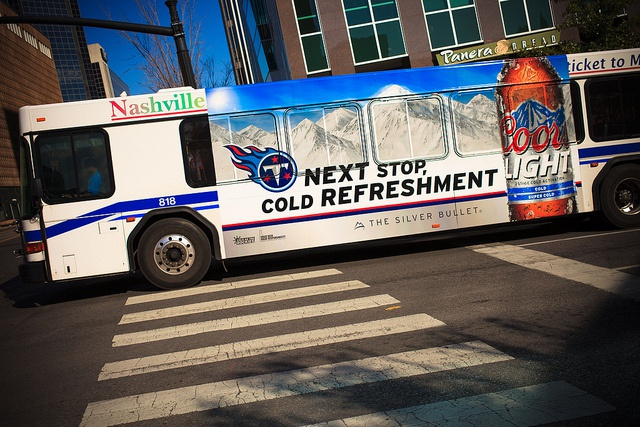Describe the objects in this image and their specific colors. I can see bus in black, ivory, tan, and darkgray tones, bottle in black, ivory, maroon, and red tones, and people in black, darkblue, and blue tones in this image. 